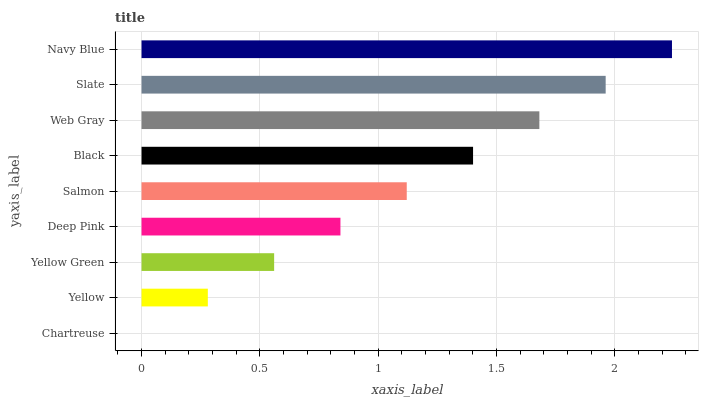Is Chartreuse the minimum?
Answer yes or no. Yes. Is Navy Blue the maximum?
Answer yes or no. Yes. Is Yellow the minimum?
Answer yes or no. No. Is Yellow the maximum?
Answer yes or no. No. Is Yellow greater than Chartreuse?
Answer yes or no. Yes. Is Chartreuse less than Yellow?
Answer yes or no. Yes. Is Chartreuse greater than Yellow?
Answer yes or no. No. Is Yellow less than Chartreuse?
Answer yes or no. No. Is Salmon the high median?
Answer yes or no. Yes. Is Salmon the low median?
Answer yes or no. Yes. Is Deep Pink the high median?
Answer yes or no. No. Is Navy Blue the low median?
Answer yes or no. No. 